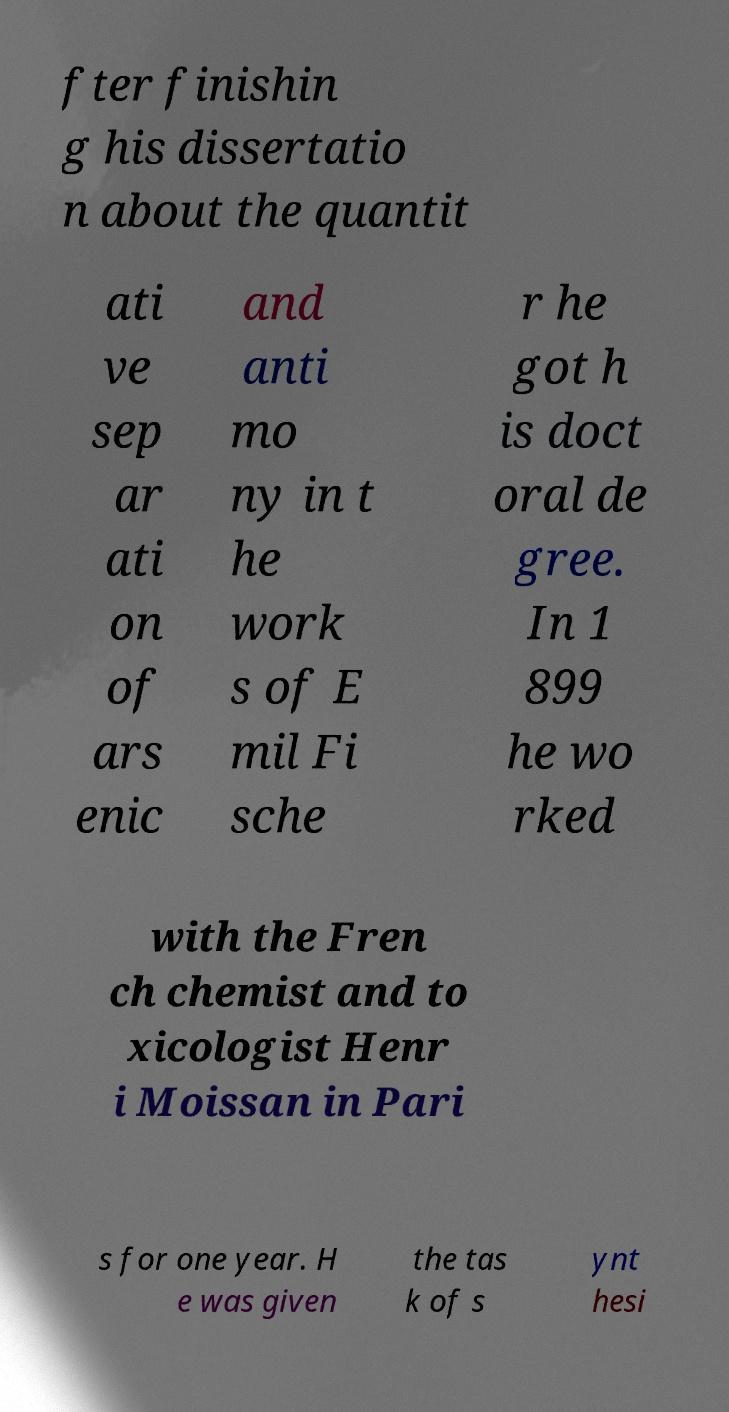Can you read and provide the text displayed in the image?This photo seems to have some interesting text. Can you extract and type it out for me? fter finishin g his dissertatio n about the quantit ati ve sep ar ati on of ars enic and anti mo ny in t he work s of E mil Fi sche r he got h is doct oral de gree. In 1 899 he wo rked with the Fren ch chemist and to xicologist Henr i Moissan in Pari s for one year. H e was given the tas k of s ynt hesi 